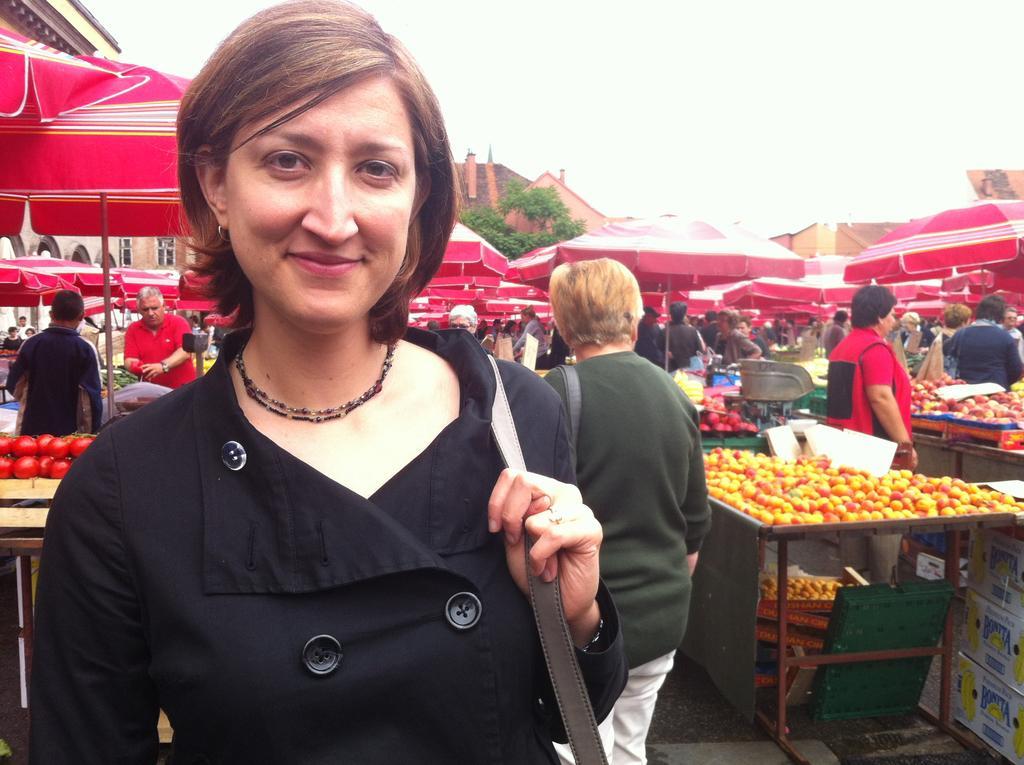In one or two sentences, can you explain what this image depicts? In this picture we can see some people are standing, a woman in the front is smiling, there are some tables and umbrellas in the middle, we can see fruits on these tables, in the background we can see a tree and a house, there is the sky at the top of the picture. 